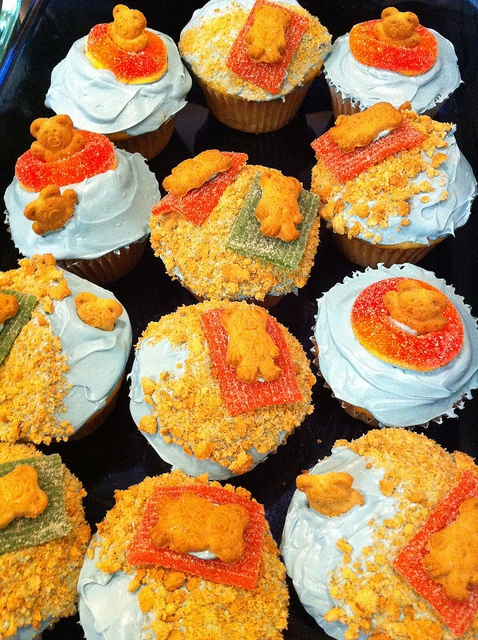Describe the objects in this image and their specific colors. I can see cake in black, orange, lightgray, and red tones, cake in black, orange, red, and beige tones, cake in black, orange, red, and gold tones, cake in black, lightblue, red, and orange tones, and cake in black, orange, lightblue, and red tones in this image. 